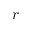Convert formula to latex. <formula><loc_0><loc_0><loc_500><loc_500>r</formula> 